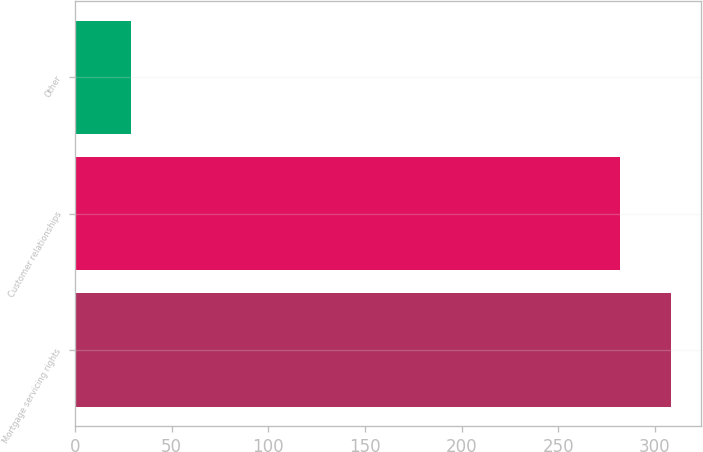Convert chart. <chart><loc_0><loc_0><loc_500><loc_500><bar_chart><fcel>Mortgage servicing rights<fcel>Customer relationships<fcel>Other<nl><fcel>308.7<fcel>282<fcel>29<nl></chart> 